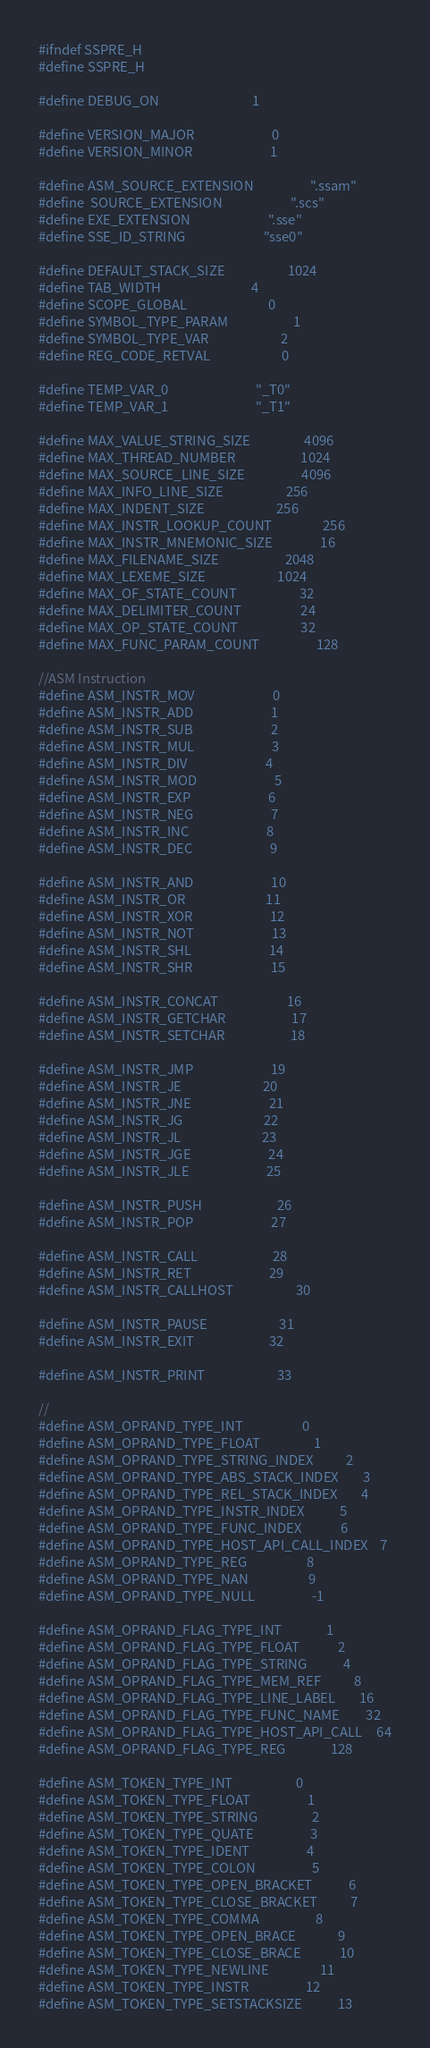<code> <loc_0><loc_0><loc_500><loc_500><_C_>#ifndef SSPRE_H
#define SSPRE_H

#define DEBUG_ON                               1

#define VERSION_MAJOR                          0
#define VERSION_MINOR                          1

#define ASM_SOURCE_EXTENSION                   ".ssam"
#define	SOURCE_EXTENSION                       ".scs"
#define EXE_EXTENSION                          ".sse"
#define SSE_ID_STRING                          "sse0"

#define DEFAULT_STACK_SIZE                     1024
#define TAB_WIDTH                              4
#define SCOPE_GLOBAL                           0
#define SYMBOL_TYPE_PARAM                      1
#define SYMBOL_TYPE_VAR                        2
#define REG_CODE_RETVAL                        0           

#define TEMP_VAR_0                             "_T0"       
#define TEMP_VAR_1                             "_T1"       

#define MAX_VALUE_STRING_SIZE                  4096
#define MAX_THREAD_NUMBER                      1024
#define MAX_SOURCE_LINE_SIZE                   4096
#define MAX_INFO_LINE_SIZE                     256
#define MAX_INDENT_SIZE                        256
#define MAX_INSTR_LOOKUP_COUNT                 256
#define MAX_INSTR_MNEMONIC_SIZE                16
#define MAX_FILENAME_SIZE                      2048
#define MAX_LEXEME_SIZE                        1024
#define MAX_OF_STATE_COUNT                     32
#define MAX_DELIMITER_COUNT                    24
#define MAX_OP_STATE_COUNT                     32
#define MAX_FUNC_PARAM_COUNT                   128

//ASM Instruction
#define ASM_INSTR_MOV                          0
#define ASM_INSTR_ADD                          1
#define ASM_INSTR_SUB                          2
#define ASM_INSTR_MUL                          3
#define ASM_INSTR_DIV                          4
#define ASM_INSTR_MOD                          5
#define ASM_INSTR_EXP                          6
#define ASM_INSTR_NEG                          7
#define ASM_INSTR_INC                          8
#define ASM_INSTR_DEC                          9

#define ASM_INSTR_AND                          10
#define ASM_INSTR_OR                           11
#define ASM_INSTR_XOR                          12
#define ASM_INSTR_NOT                          13
#define ASM_INSTR_SHL                          14
#define ASM_INSTR_SHR                          15
								               
#define ASM_INSTR_CONCAT                       16
#define ASM_INSTR_GETCHAR                      17
#define ASM_INSTR_SETCHAR                      18
								               
#define ASM_INSTR_JMP                          19
#define ASM_INSTR_JE                           20
#define ASM_INSTR_JNE                          21
#define ASM_INSTR_JG                           22
#define ASM_INSTR_JL                           23
#define ASM_INSTR_JGE                          24
#define ASM_INSTR_JLE                          25
								               
#define ASM_INSTR_PUSH                         26
#define ASM_INSTR_POP                          27
								               
#define ASM_INSTR_CALL                         28
#define ASM_INSTR_RET                          29
#define ASM_INSTR_CALLHOST                     30
								               
#define ASM_INSTR_PAUSE                        31
#define ASM_INSTR_EXIT                         32
								               
#define ASM_INSTR_PRINT                        33

//
#define ASM_OPRAND_TYPE_INT                    0
#define ASM_OPRAND_TYPE_FLOAT                  1
#define ASM_OPRAND_TYPE_STRING_INDEX           2
#define ASM_OPRAND_TYPE_ABS_STACK_INDEX        3
#define ASM_OPRAND_TYPE_REL_STACK_INDEX        4
#define ASM_OPRAND_TYPE_INSTR_INDEX            5
#define ASM_OPRAND_TYPE_FUNC_INDEX             6
#define ASM_OPRAND_TYPE_HOST_API_CALL_INDEX    7
#define ASM_OPRAND_TYPE_REG                    8
#define ASM_OPRAND_TYPE_NAN                    9
#define ASM_OPRAND_TYPE_NULL                   -1
											   
#define ASM_OPRAND_FLAG_TYPE_INT               1
#define ASM_OPRAND_FLAG_TYPE_FLOAT             2
#define ASM_OPRAND_FLAG_TYPE_STRING            4
#define ASM_OPRAND_FLAG_TYPE_MEM_REF           8
#define ASM_OPRAND_FLAG_TYPE_LINE_LABEL        16
#define ASM_OPRAND_FLAG_TYPE_FUNC_NAME         32
#define ASM_OPRAND_FLAG_TYPE_HOST_API_CALL     64
#define ASM_OPRAND_FLAG_TYPE_REG               128

#define ASM_TOKEN_TYPE_INT                     0
#define ASM_TOKEN_TYPE_FLOAT                   1
#define ASM_TOKEN_TYPE_STRING                  2
#define ASM_TOKEN_TYPE_QUATE                   3
#define ASM_TOKEN_TYPE_IDENT                   4
#define ASM_TOKEN_TYPE_COLON                   5
#define ASM_TOKEN_TYPE_OPEN_BRACKET            6
#define ASM_TOKEN_TYPE_CLOSE_BRACKET           7
#define ASM_TOKEN_TYPE_COMMA                   8
#define ASM_TOKEN_TYPE_OPEN_BRACE              9
#define ASM_TOKEN_TYPE_CLOSE_BRACE             10
#define ASM_TOKEN_TYPE_NEWLINE                 11
#define ASM_TOKEN_TYPE_INSTR                   12
#define ASM_TOKEN_TYPE_SETSTACKSIZE            13</code> 